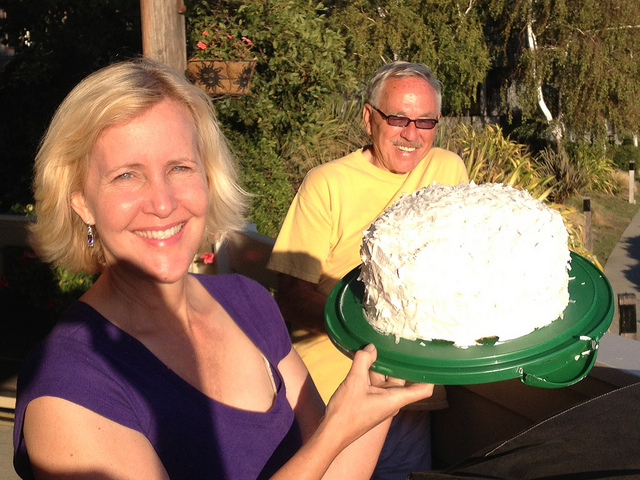Can you comment on the mood in the photo? The mood appears cheerful and celebratory. The smiles on their faces and the presence of the cake suggest a festive atmosphere and a moment of happiness. 